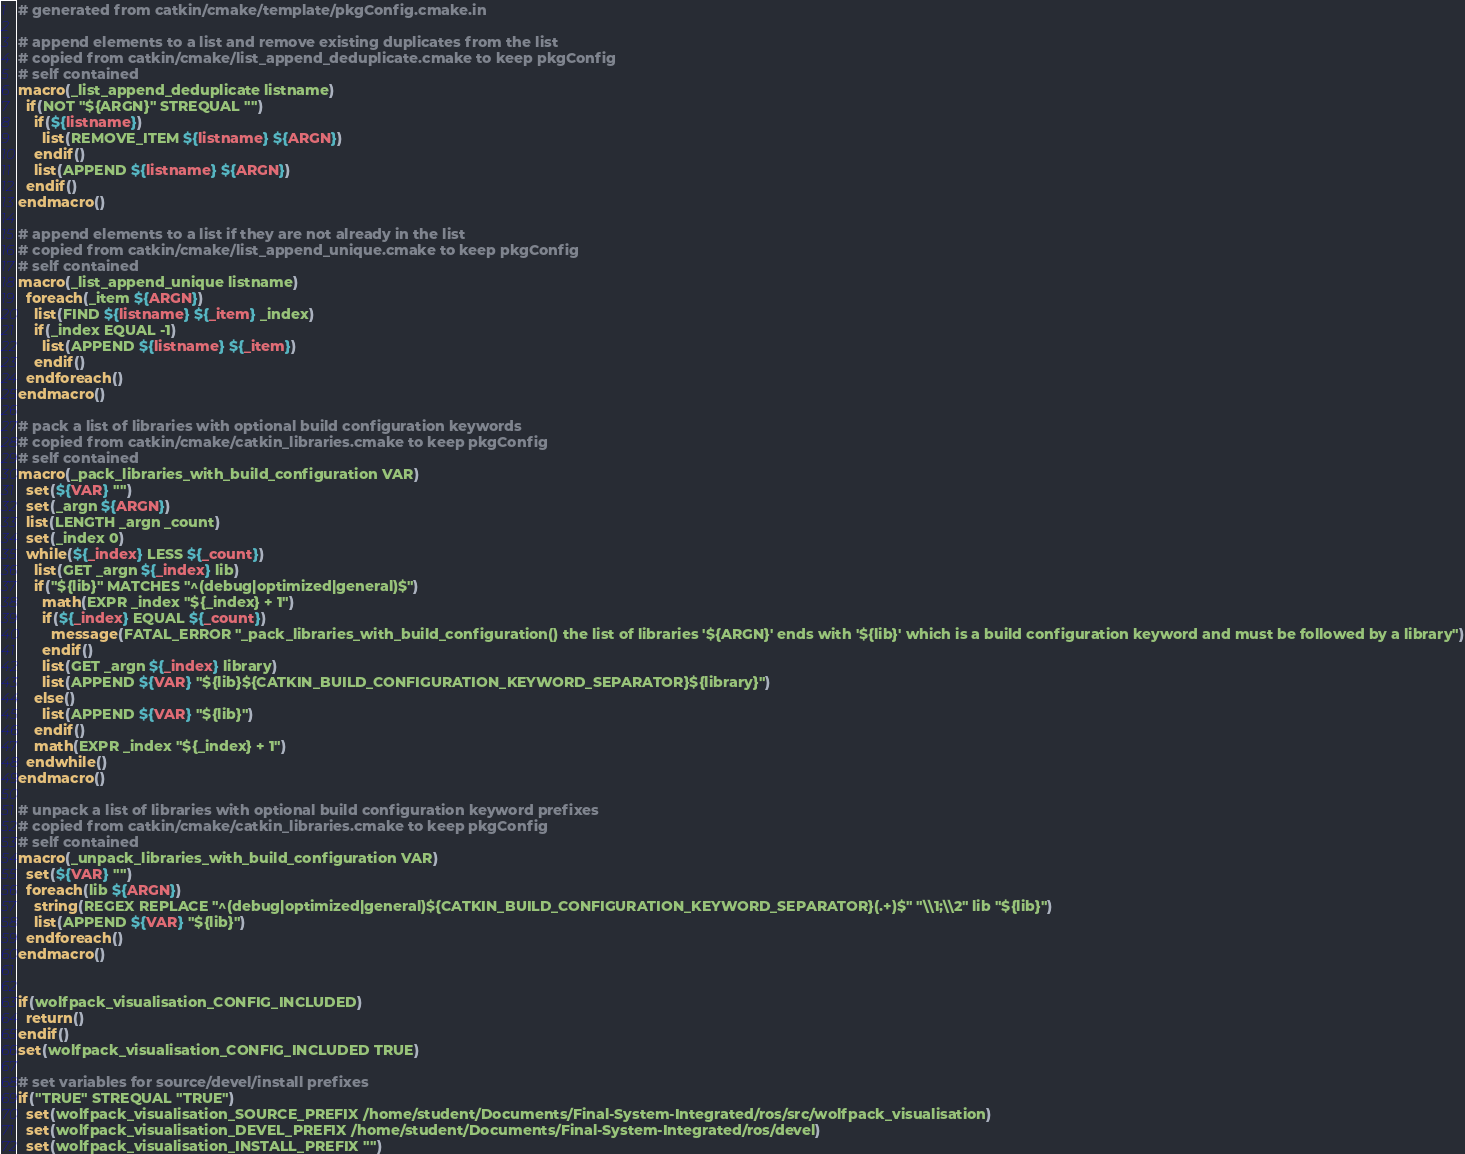Convert code to text. <code><loc_0><loc_0><loc_500><loc_500><_CMake_># generated from catkin/cmake/template/pkgConfig.cmake.in

# append elements to a list and remove existing duplicates from the list
# copied from catkin/cmake/list_append_deduplicate.cmake to keep pkgConfig
# self contained
macro(_list_append_deduplicate listname)
  if(NOT "${ARGN}" STREQUAL "")
    if(${listname})
      list(REMOVE_ITEM ${listname} ${ARGN})
    endif()
    list(APPEND ${listname} ${ARGN})
  endif()
endmacro()

# append elements to a list if they are not already in the list
# copied from catkin/cmake/list_append_unique.cmake to keep pkgConfig
# self contained
macro(_list_append_unique listname)
  foreach(_item ${ARGN})
    list(FIND ${listname} ${_item} _index)
    if(_index EQUAL -1)
      list(APPEND ${listname} ${_item})
    endif()
  endforeach()
endmacro()

# pack a list of libraries with optional build configuration keywords
# copied from catkin/cmake/catkin_libraries.cmake to keep pkgConfig
# self contained
macro(_pack_libraries_with_build_configuration VAR)
  set(${VAR} "")
  set(_argn ${ARGN})
  list(LENGTH _argn _count)
  set(_index 0)
  while(${_index} LESS ${_count})
    list(GET _argn ${_index} lib)
    if("${lib}" MATCHES "^(debug|optimized|general)$")
      math(EXPR _index "${_index} + 1")
      if(${_index} EQUAL ${_count})
        message(FATAL_ERROR "_pack_libraries_with_build_configuration() the list of libraries '${ARGN}' ends with '${lib}' which is a build configuration keyword and must be followed by a library")
      endif()
      list(GET _argn ${_index} library)
      list(APPEND ${VAR} "${lib}${CATKIN_BUILD_CONFIGURATION_KEYWORD_SEPARATOR}${library}")
    else()
      list(APPEND ${VAR} "${lib}")
    endif()
    math(EXPR _index "${_index} + 1")
  endwhile()
endmacro()

# unpack a list of libraries with optional build configuration keyword prefixes
# copied from catkin/cmake/catkin_libraries.cmake to keep pkgConfig
# self contained
macro(_unpack_libraries_with_build_configuration VAR)
  set(${VAR} "")
  foreach(lib ${ARGN})
    string(REGEX REPLACE "^(debug|optimized|general)${CATKIN_BUILD_CONFIGURATION_KEYWORD_SEPARATOR}(.+)$" "\\1;\\2" lib "${lib}")
    list(APPEND ${VAR} "${lib}")
  endforeach()
endmacro()


if(wolfpack_visualisation_CONFIG_INCLUDED)
  return()
endif()
set(wolfpack_visualisation_CONFIG_INCLUDED TRUE)

# set variables for source/devel/install prefixes
if("TRUE" STREQUAL "TRUE")
  set(wolfpack_visualisation_SOURCE_PREFIX /home/student/Documents/Final-System-Integrated/ros/src/wolfpack_visualisation)
  set(wolfpack_visualisation_DEVEL_PREFIX /home/student/Documents/Final-System-Integrated/ros/devel)
  set(wolfpack_visualisation_INSTALL_PREFIX "")</code> 